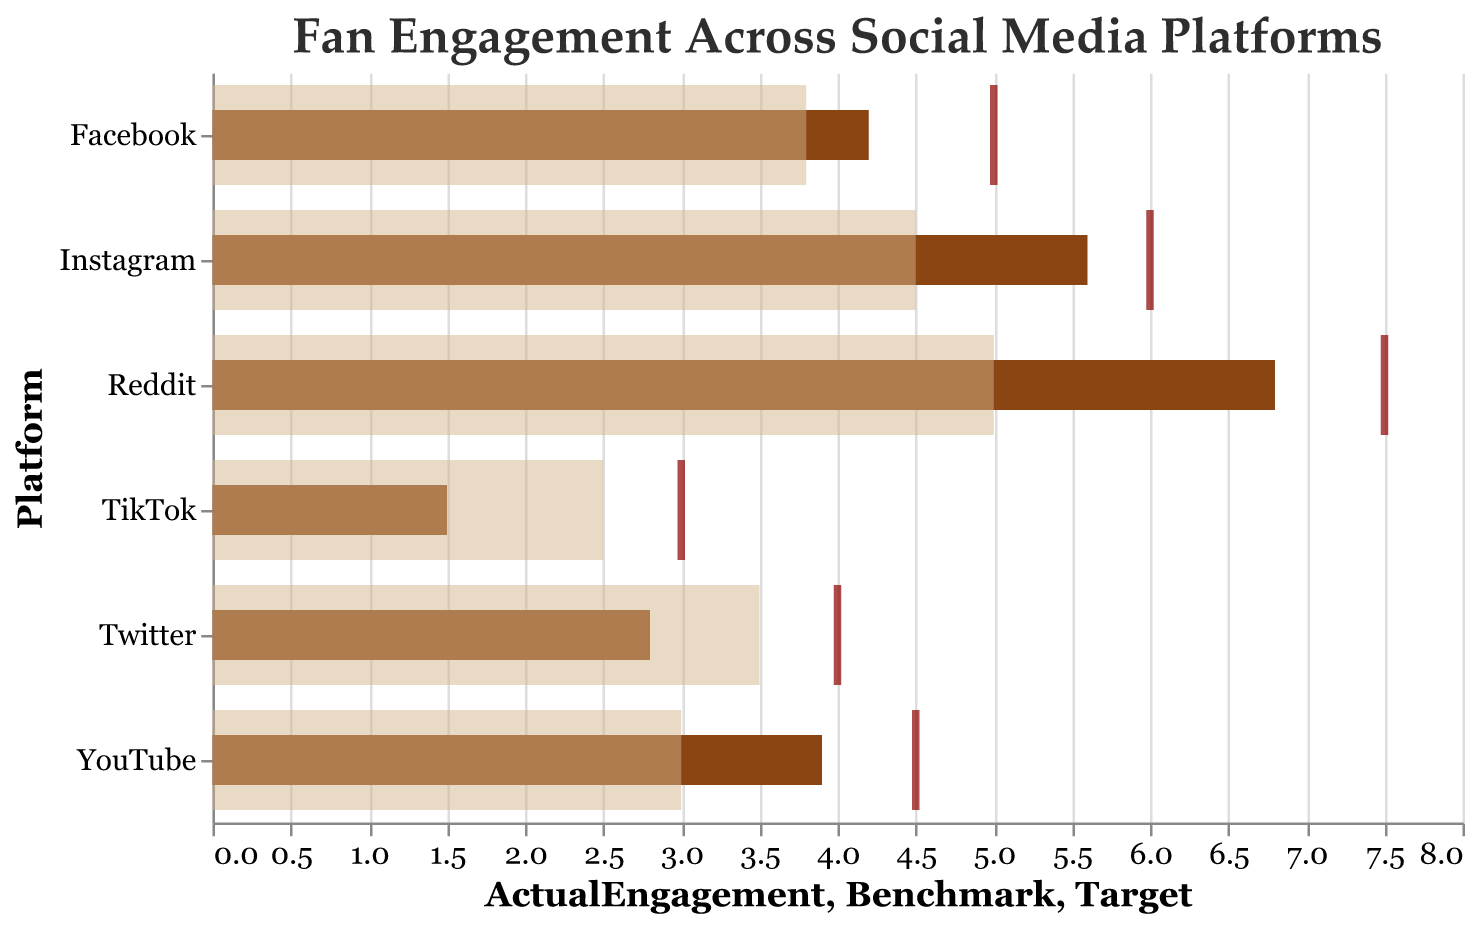What is the title of the chart? The title of the chart is usually located at the top and reads: "Fan Engagement Across Social Media Platforms."
Answer: Fan Engagement Across Social Media Platforms Which platform has the highest actual engagement? By observing the length of the bars, Reddit has the longest dark bar, indicating the highest actual engagement.
Answer: Reddit How does the actual engagement on Instagram compare to the benchmark? Compare the bar's length (dark brown, representing actual engagement) to the tan bar (representing the benchmark). The dark brown bar for Instagram exceeds the tan bar denoting it surpasses the benchmark.
Answer: Surpasses What is the target engagement for Facebook? The target engagement is indicated by a tick mark in dark red. For Facebook, the tick mark is positioned at 5.0 on the horizontal axis.
Answer: 5.0 Sum the actual engagements of Twitter and TikTok. Add the values of the actual engagements for Twitter (2.8) and TikTok (1.5). The sum is 2.8 + 1.5 = 4.3
Answer: 4.3 Which platform's actual engagement is closest to its target? Compare the actual engagement bars (dark brown) with the position of the red tick marks for each platform. YouTube's actual engagement of 3.9 is the closest to its target of 4.5.
Answer: YouTube What is the difference between Twitter's actual engagement and its benchmark? Subtract Twitter's actual engagement (2.8) from its benchmark (3.5). The difference is 3.5 - 2.8 = 0.7
Answer: 0.7 What is the visual appearance of the benchmark engagement representation? The benchmark engagements are represented as tan bars with 50% opacity and are thicker than the actual engagement bars.
Answer: Tan, thicker, 50% opacity Which platform has the lowest actual engagement? The platform with the shortest dark bar is TikTok, indicating the lowest actual engagement.
Answer: TikTok Is any platform's actual engagement lower than both its benchmark and target? Checking each platform visually, TikTok’s actual engagement (1.5) is lower than both its benchmark (2.5) and its target (3.0).
Answer: Yes, TikTok 